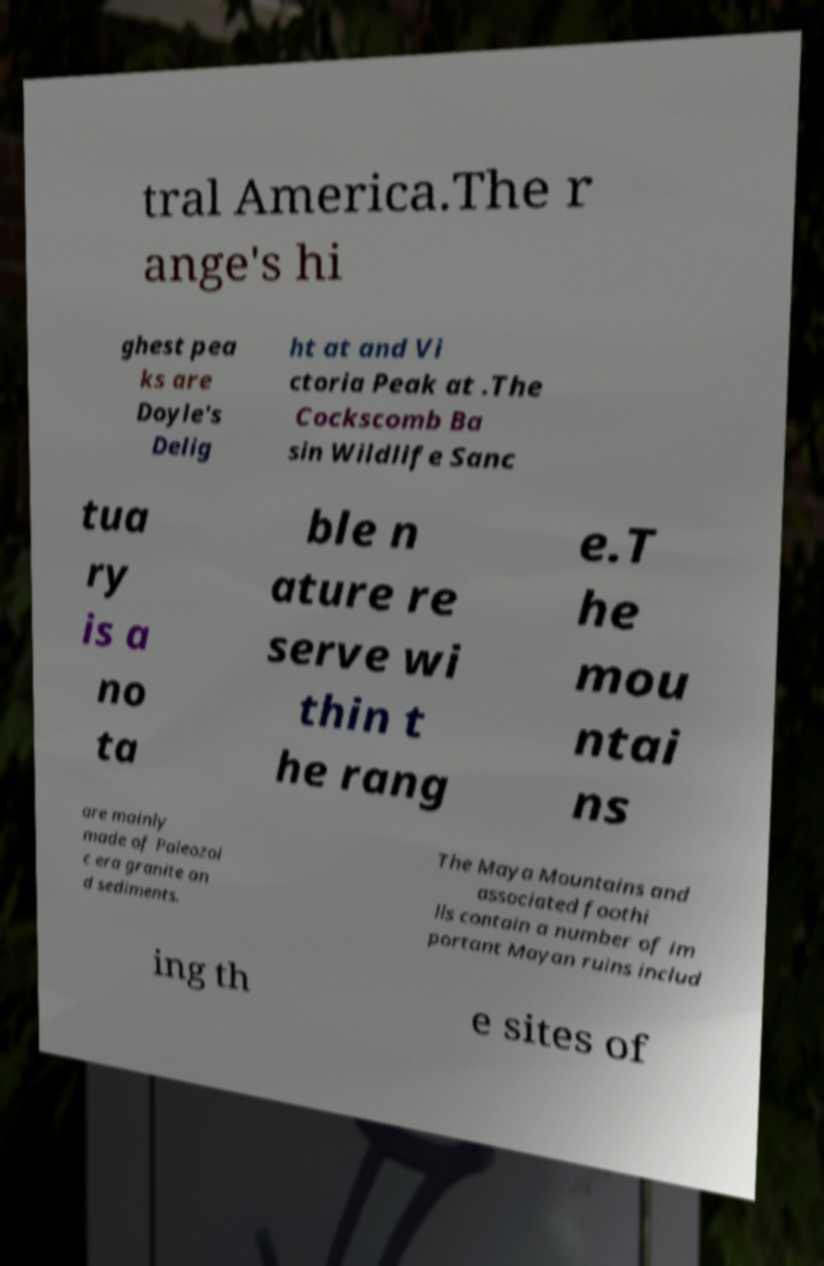What messages or text are displayed in this image? I need them in a readable, typed format. tral America.The r ange's hi ghest pea ks are Doyle's Delig ht at and Vi ctoria Peak at .The Cockscomb Ba sin Wildlife Sanc tua ry is a no ta ble n ature re serve wi thin t he rang e.T he mou ntai ns are mainly made of Paleozoi c era granite an d sediments. The Maya Mountains and associated foothi lls contain a number of im portant Mayan ruins includ ing th e sites of 